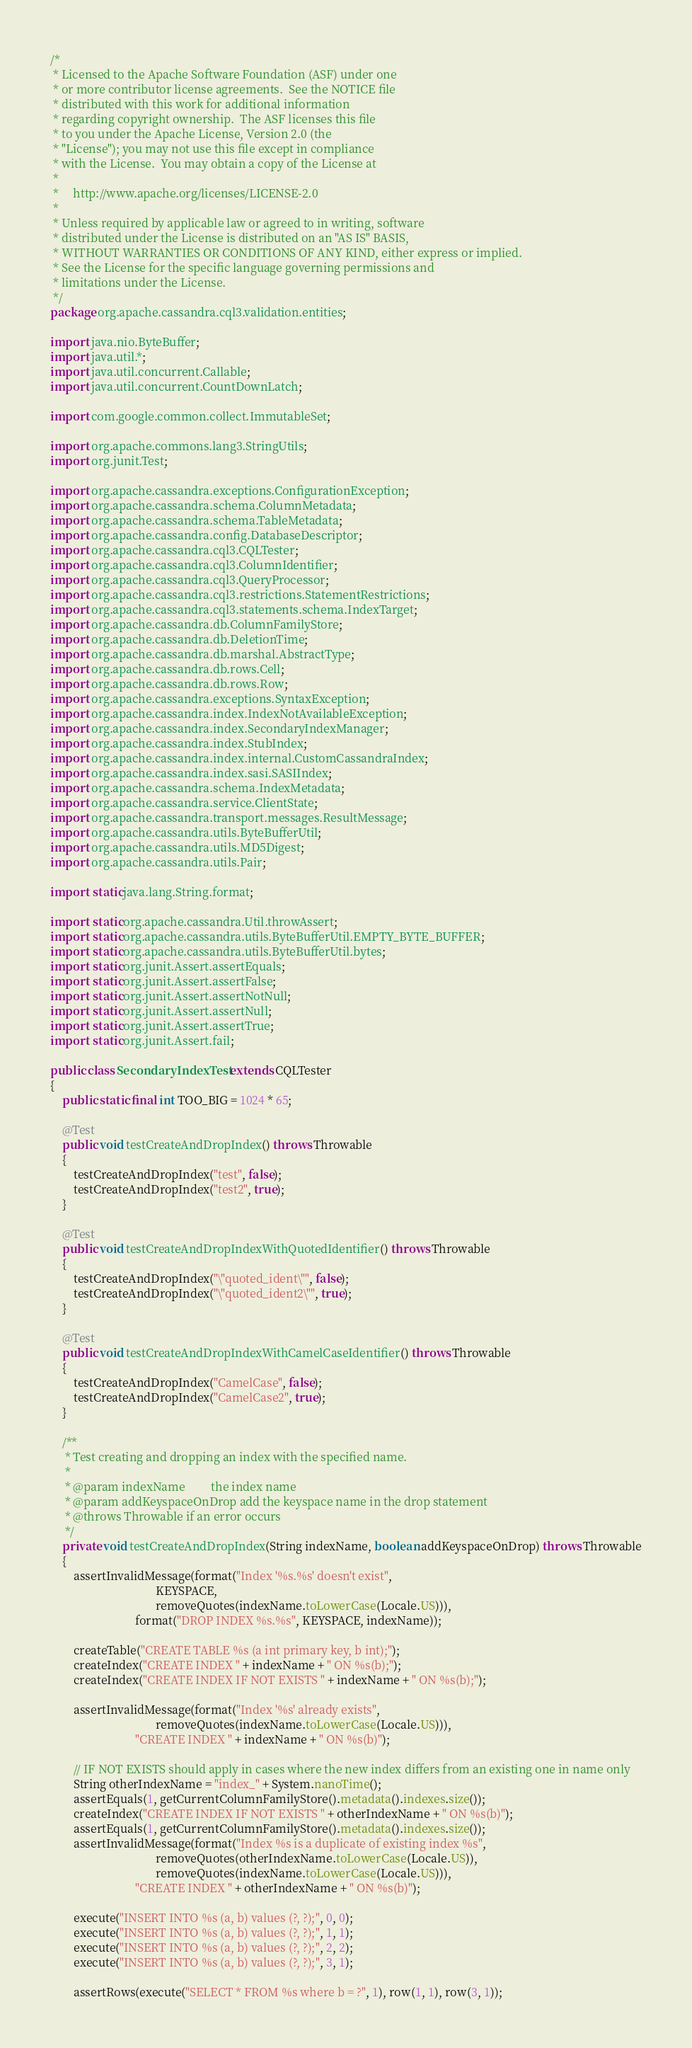Convert code to text. <code><loc_0><loc_0><loc_500><loc_500><_Java_>/*
 * Licensed to the Apache Software Foundation (ASF) under one
 * or more contributor license agreements.  See the NOTICE file
 * distributed with this work for additional information
 * regarding copyright ownership.  The ASF licenses this file
 * to you under the Apache License, Version 2.0 (the
 * "License"); you may not use this file except in compliance
 * with the License.  You may obtain a copy of the License at
 *
 *     http://www.apache.org/licenses/LICENSE-2.0
 *
 * Unless required by applicable law or agreed to in writing, software
 * distributed under the License is distributed on an "AS IS" BASIS,
 * WITHOUT WARRANTIES OR CONDITIONS OF ANY KIND, either express or implied.
 * See the License for the specific language governing permissions and
 * limitations under the License.
 */
package org.apache.cassandra.cql3.validation.entities;

import java.nio.ByteBuffer;
import java.util.*;
import java.util.concurrent.Callable;
import java.util.concurrent.CountDownLatch;

import com.google.common.collect.ImmutableSet;

import org.apache.commons.lang3.StringUtils;
import org.junit.Test;

import org.apache.cassandra.exceptions.ConfigurationException;
import org.apache.cassandra.schema.ColumnMetadata;
import org.apache.cassandra.schema.TableMetadata;
import org.apache.cassandra.config.DatabaseDescriptor;
import org.apache.cassandra.cql3.CQLTester;
import org.apache.cassandra.cql3.ColumnIdentifier;
import org.apache.cassandra.cql3.QueryProcessor;
import org.apache.cassandra.cql3.restrictions.StatementRestrictions;
import org.apache.cassandra.cql3.statements.schema.IndexTarget;
import org.apache.cassandra.db.ColumnFamilyStore;
import org.apache.cassandra.db.DeletionTime;
import org.apache.cassandra.db.marshal.AbstractType;
import org.apache.cassandra.db.rows.Cell;
import org.apache.cassandra.db.rows.Row;
import org.apache.cassandra.exceptions.SyntaxException;
import org.apache.cassandra.index.IndexNotAvailableException;
import org.apache.cassandra.index.SecondaryIndexManager;
import org.apache.cassandra.index.StubIndex;
import org.apache.cassandra.index.internal.CustomCassandraIndex;
import org.apache.cassandra.index.sasi.SASIIndex;
import org.apache.cassandra.schema.IndexMetadata;
import org.apache.cassandra.service.ClientState;
import org.apache.cassandra.transport.messages.ResultMessage;
import org.apache.cassandra.utils.ByteBufferUtil;
import org.apache.cassandra.utils.MD5Digest;
import org.apache.cassandra.utils.Pair;

import static java.lang.String.format;

import static org.apache.cassandra.Util.throwAssert;
import static org.apache.cassandra.utils.ByteBufferUtil.EMPTY_BYTE_BUFFER;
import static org.apache.cassandra.utils.ByteBufferUtil.bytes;
import static org.junit.Assert.assertEquals;
import static org.junit.Assert.assertFalse;
import static org.junit.Assert.assertNotNull;
import static org.junit.Assert.assertNull;
import static org.junit.Assert.assertTrue;
import static org.junit.Assert.fail;

public class SecondaryIndexTest extends CQLTester
{
    public static final int TOO_BIG = 1024 * 65;

    @Test
    public void testCreateAndDropIndex() throws Throwable
    {
        testCreateAndDropIndex("test", false);
        testCreateAndDropIndex("test2", true);
    }

    @Test
    public void testCreateAndDropIndexWithQuotedIdentifier() throws Throwable
    {
        testCreateAndDropIndex("\"quoted_ident\"", false);
        testCreateAndDropIndex("\"quoted_ident2\"", true);
    }

    @Test
    public void testCreateAndDropIndexWithCamelCaseIdentifier() throws Throwable
    {
        testCreateAndDropIndex("CamelCase", false);
        testCreateAndDropIndex("CamelCase2", true);
    }

    /**
     * Test creating and dropping an index with the specified name.
     *
     * @param indexName         the index name
     * @param addKeyspaceOnDrop add the keyspace name in the drop statement
     * @throws Throwable if an error occurs
     */
    private void testCreateAndDropIndex(String indexName, boolean addKeyspaceOnDrop) throws Throwable
    {
        assertInvalidMessage(format("Index '%s.%s' doesn't exist",
                                    KEYSPACE,
                                    removeQuotes(indexName.toLowerCase(Locale.US))),
                             format("DROP INDEX %s.%s", KEYSPACE, indexName));

        createTable("CREATE TABLE %s (a int primary key, b int);");
        createIndex("CREATE INDEX " + indexName + " ON %s(b);");
        createIndex("CREATE INDEX IF NOT EXISTS " + indexName + " ON %s(b);");

        assertInvalidMessage(format("Index '%s' already exists",
                                    removeQuotes(indexName.toLowerCase(Locale.US))),
                             "CREATE INDEX " + indexName + " ON %s(b)");

        // IF NOT EXISTS should apply in cases where the new index differs from an existing one in name only
        String otherIndexName = "index_" + System.nanoTime();
        assertEquals(1, getCurrentColumnFamilyStore().metadata().indexes.size());
        createIndex("CREATE INDEX IF NOT EXISTS " + otherIndexName + " ON %s(b)");
        assertEquals(1, getCurrentColumnFamilyStore().metadata().indexes.size());
        assertInvalidMessage(format("Index %s is a duplicate of existing index %s",
                                    removeQuotes(otherIndexName.toLowerCase(Locale.US)),
                                    removeQuotes(indexName.toLowerCase(Locale.US))),
                             "CREATE INDEX " + otherIndexName + " ON %s(b)");

        execute("INSERT INTO %s (a, b) values (?, ?);", 0, 0);
        execute("INSERT INTO %s (a, b) values (?, ?);", 1, 1);
        execute("INSERT INTO %s (a, b) values (?, ?);", 2, 2);
        execute("INSERT INTO %s (a, b) values (?, ?);", 3, 1);

        assertRows(execute("SELECT * FROM %s where b = ?", 1), row(1, 1), row(3, 1));
</code> 